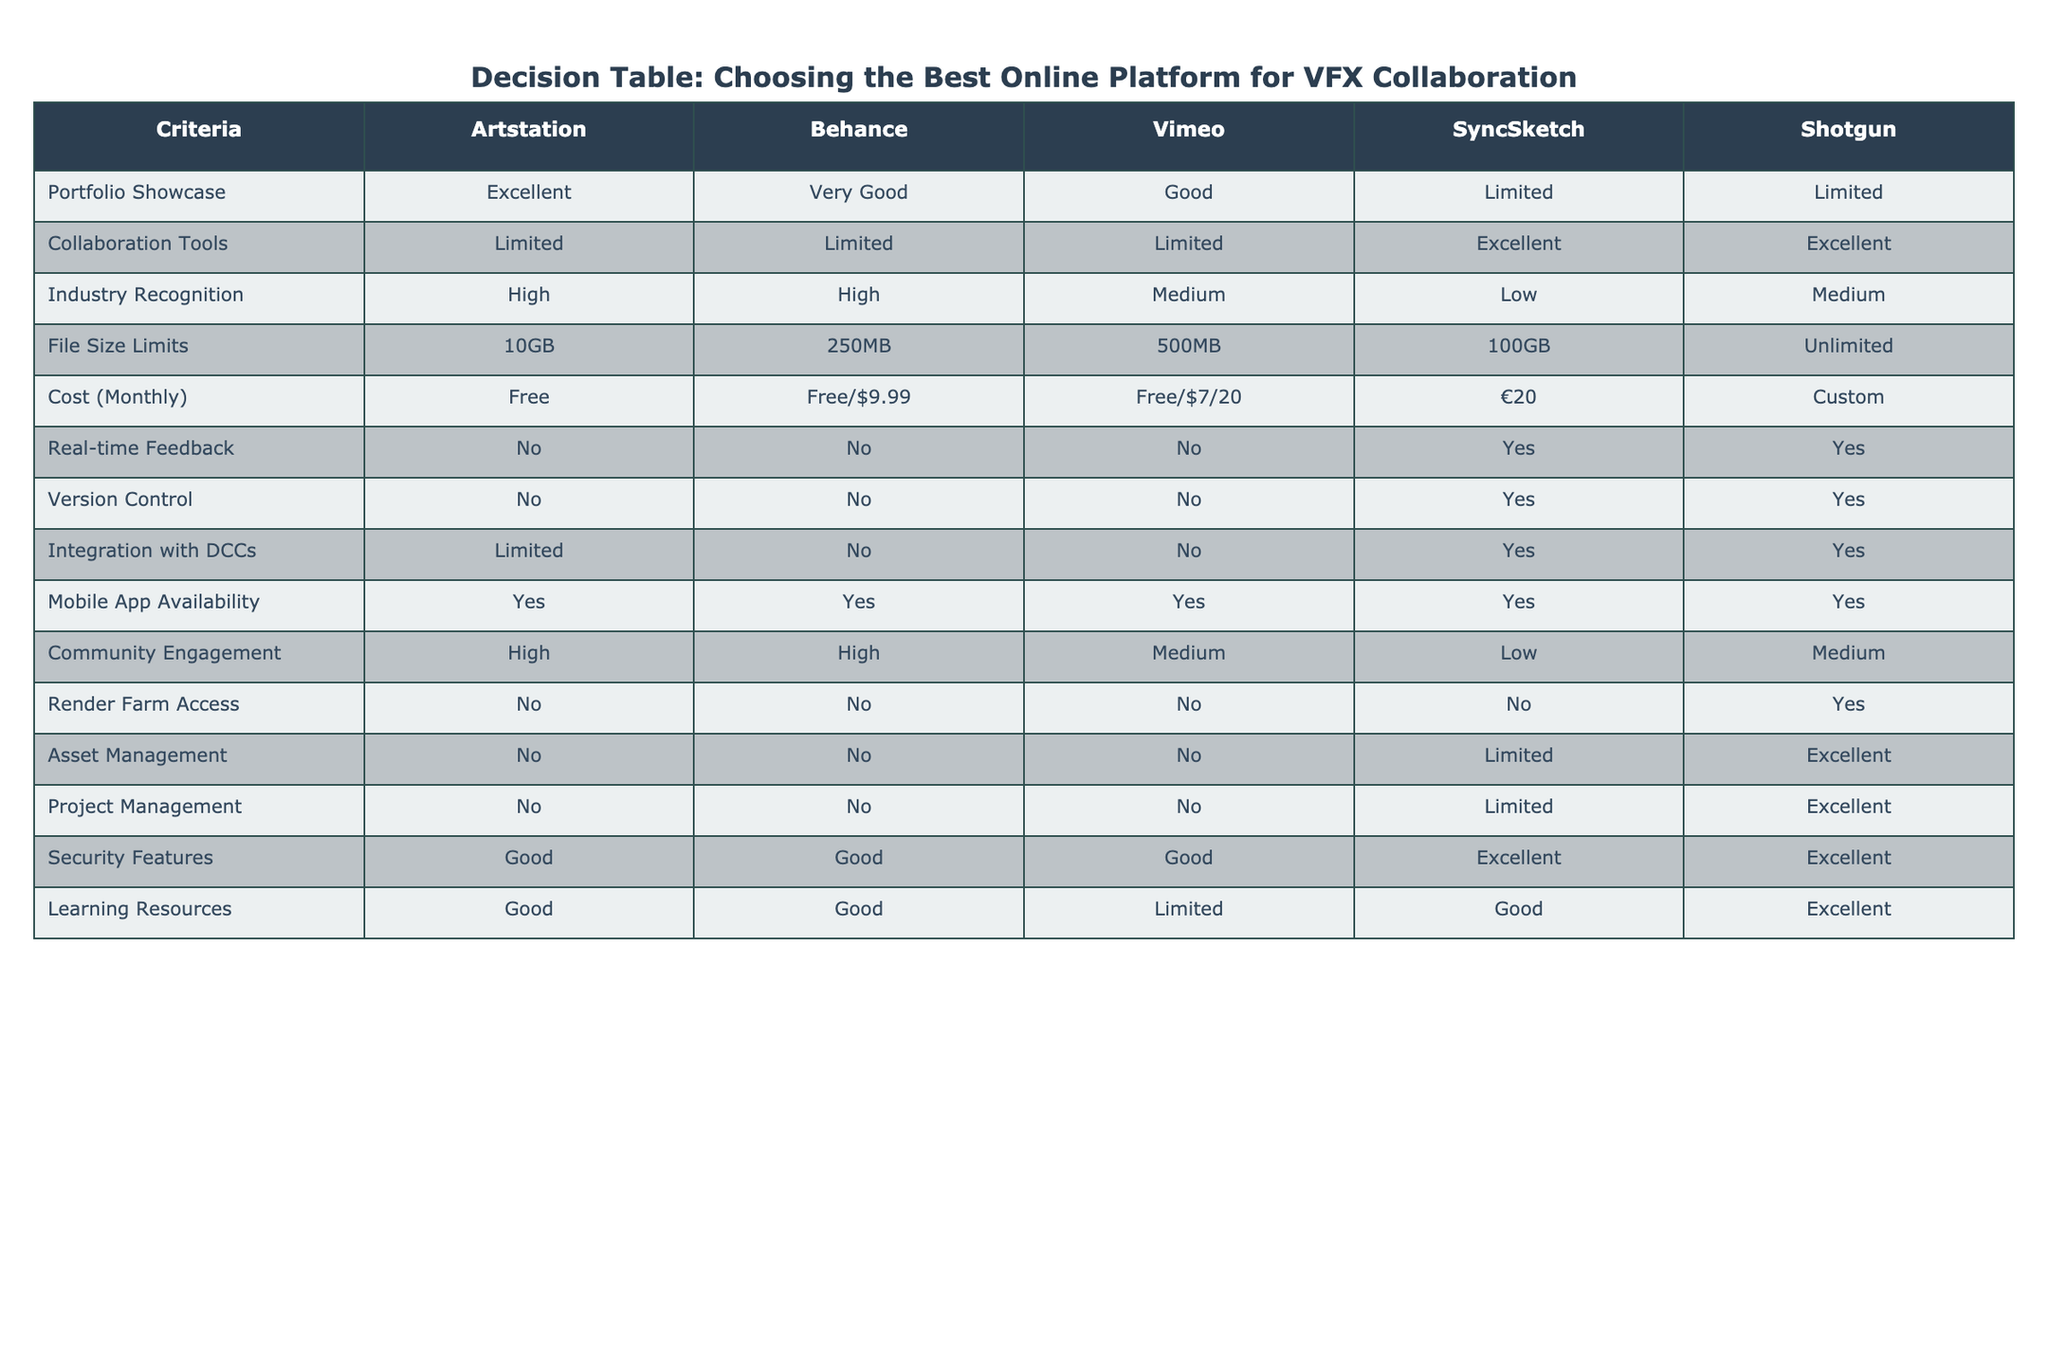What is the monthly cost of using Shotgun? The monthly cost for Shotgun is listed as custom in the table, indicating that it varies based on usage or specific requirements rather than a fixed price.
Answer: Custom Which platform has the highest file size limit? Reviewing the file size limits in the table, Shotgun has an unlimited file size limit, which is the highest when compared to the other platforms.
Answer: Unlimited Does SyncSketch offer real-time feedback? By examining the table, we can see that SyncSketch is marked as "Yes" under real-time feedback, confirming that it does provide this feature.
Answer: Yes What is the primary strength of ArtStation in terms of portfolio display? The table indicates that ArtStation excels in portfolio showcase with an "Excellent" rating, meaning it is highly effective for displaying work.
Answer: Excellent If we were to sum the community engagement ratings of all platforms, would they be above 2? The community engagement ratings are High (2), High (2), Medium (1), Low (0), and Medium (1). Summing these values gives us: 2 + 2 + 1 + 0 + 1 = 6, which is indeed above 2.
Answer: Yes Which platform(s) provide excellent collaboration tools? The table shows that both SyncSketch and Shotgun are marked as having "Excellent" collaboration tools, making them the only platforms with this feature.
Answer: SyncSketch, Shotgun What is the difference in mobile app availability between Shotgun and Vimeo? Both Shotgun and Vimeo show "Yes" under mobile app availability, indicating that there is no difference; both platforms provide mobile applications.
Answer: No difference How many platforms have high industry recognition? According to the table, both ArtStation and Behance have "High" industry recognition ratings. Therefore, there are 2 platforms with high recognition.
Answer: 2 Which platform is the best in terms of asset management? The table ranks Shotgun as "Excellent" for asset management, which is better than the limited rating of SyncSketch and the no access of others, indicating its superiority in this area.
Answer: Shotgun 